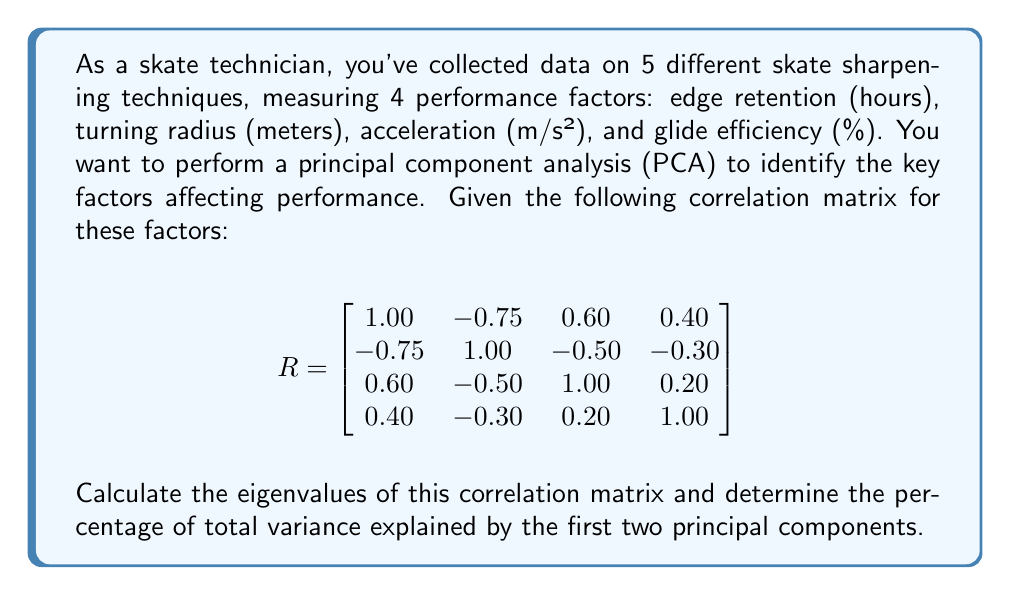Provide a solution to this math problem. To solve this problem, we need to follow these steps:

1) First, we need to find the eigenvalues of the correlation matrix R. The eigenvalues λ are the solutions to the characteristic equation:

   $$det(R - \lambda I) = 0$$

   Where I is the 4x4 identity matrix.

2) Expanding this determinant leads to a 4th degree polynomial equation. Solving this equation (usually done with computer software) gives us the eigenvalues.

3) For this correlation matrix, the eigenvalues are:

   $$\lambda_1 = 2.4563$$
   $$\lambda_2 = 0.8924$$
   $$\lambda_3 = 0.4154$$
   $$\lambda_4 = 0.2359$$

4) In PCA, each eigenvalue represents the amount of variance explained by its corresponding principal component. The total variance is equal to the sum of all eigenvalues.

5) To calculate the percentage of total variance explained by the first two principal components:

   a) Calculate the total variance:
      $$Total variance = 2.4563 + 0.8924 + 0.4154 + 0.2359 = 4$$

   b) Calculate the variance explained by the first two components:
      $$Variance_{PC1 + PC2} = 2.4563 + 0.8924 = 3.3487$$

   c) Calculate the percentage:
      $$Percentage = \frac{3.3487}{4} \times 100\% = 83.72\%$$

Therefore, the first two principal components explain 83.72% of the total variance in the data.
Answer: The first two principal components explain 83.72% of the total variance in the skate sharpening performance data. 